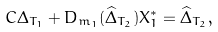Convert formula to latex. <formula><loc_0><loc_0><loc_500><loc_500>C \Delta _ { { T } _ { 1 } } + D _ { m _ { 1 } } ( \widehat { \Delta } _ { { T } _ { 2 } } ) { X } _ { 1 } ^ { * } = \widehat { \Delta } _ { { T } _ { 2 } } ,</formula> 